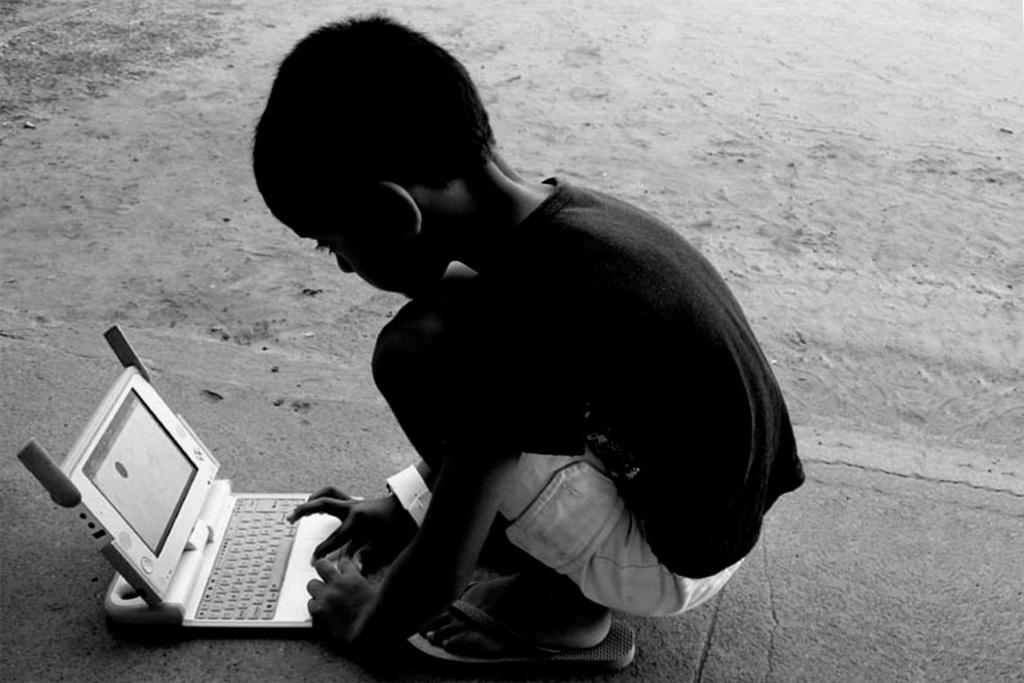Who is the main subject in the image? There is a small boy in the image. What else can be seen in the foreground area of the image? There is a gadget in the image. Can you describe the location of the boy and the gadget in the image? Both the boy and the gadget are in the foreground area of the image. What type of park can be seen in the background of the image? There is no park visible in the image; it only features a small boy and a gadget in the foreground area. 